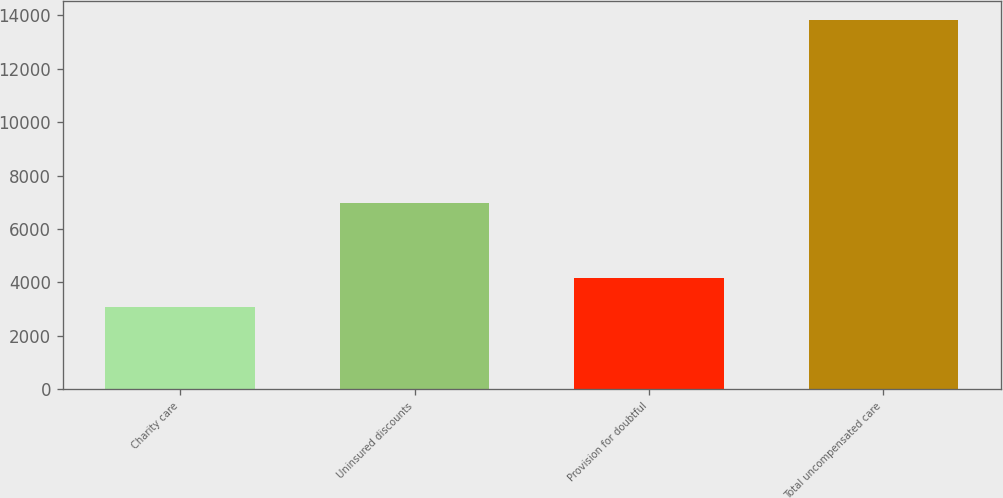Convert chart. <chart><loc_0><loc_0><loc_500><loc_500><bar_chart><fcel>Charity care<fcel>Uninsured discounts<fcel>Provision for doubtful<fcel>Total uncompensated care<nl><fcel>3093<fcel>6978<fcel>4167.8<fcel>13841<nl></chart> 